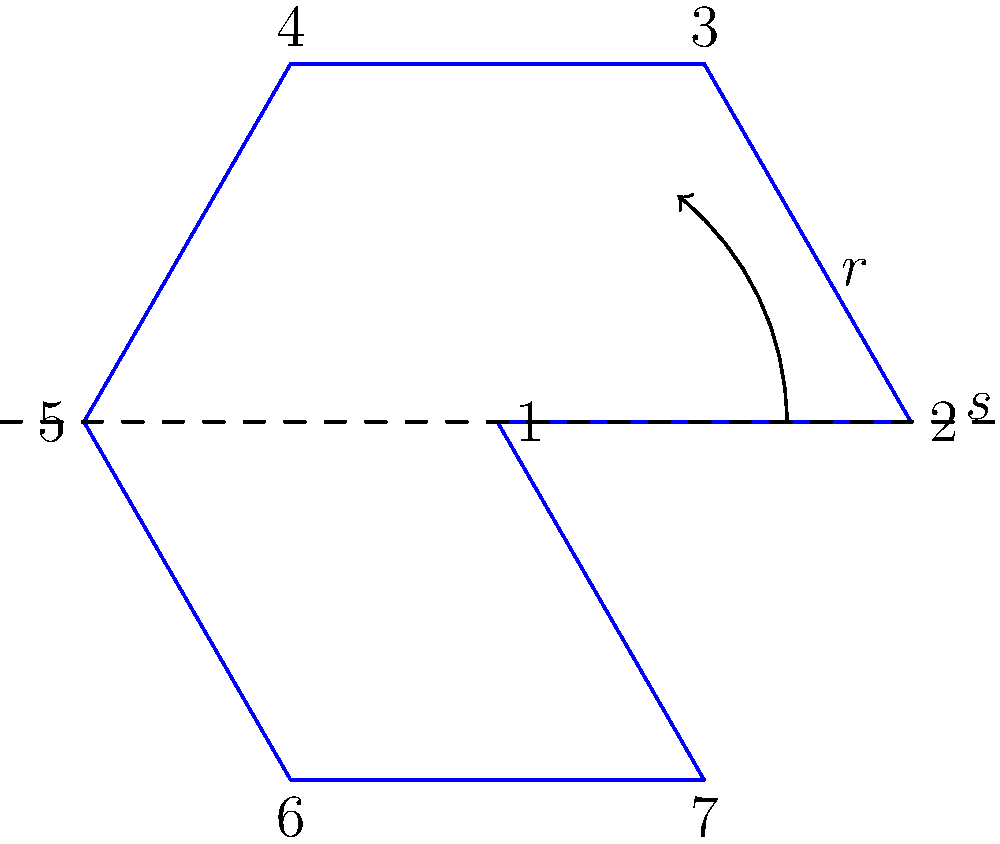In the diagram above, an orchestra's seating arrangement is represented by a regular heptagon, where each vertex corresponds to a section of the orchestra. The arrangement exhibits symmetries of the dihedral group $D_7$. If $r$ represents a counterclockwise rotation by $\frac{2\pi}{7}$ and $s$ represents a reflection across the horizontal axis, what is the result of applying the transformation $rs^2$ to the orchestra section labeled 1? Let's approach this step-by-step:

1) First, we need to understand what $rs^2$ means:
   - $s^2$ means applying the reflection $s$ twice
   - $r$ means rotating counterclockwise by $\frac{2\pi}{7}$
   - The operations are applied from right to left

2) Let's apply $s^2$ first:
   - $s$ reflects section 1 across the horizontal axis to position 7
   - Applying $s$ again reflects 7 back to 1
   - So $s^2$ is equivalent to the identity transformation

3) Now we apply $r$ to the result:
   - Since $s^2$ didn't change the position, we're still at 1
   - $r$ rotates counterclockwise by $\frac{2\pi}{7}$, moving from 1 to 2

4) Therefore, the final position after applying $rs^2$ to section 1 is 2.

This problem demonstrates how the dihedral group $D_7$ operates on the orchestra seating arrangement, showcasing the interplay between rotations and reflections in group theory.
Answer: 2 